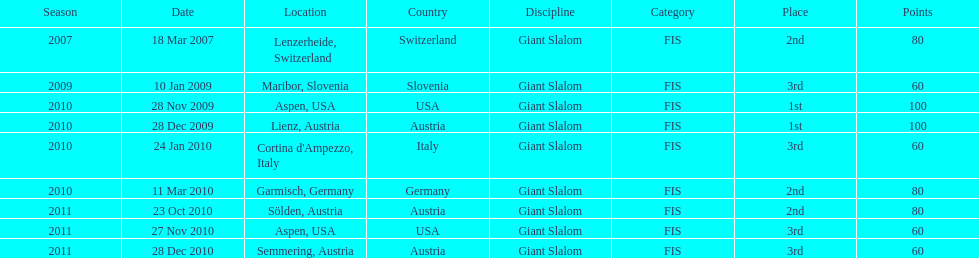What was the finishing place of the last race in december 2010? 3rd. I'm looking to parse the entire table for insights. Could you assist me with that? {'header': ['Season', 'Date', 'Location', 'Country', 'Discipline', 'Category', 'Place', 'Points'], 'rows': [['2007', '18 Mar 2007', 'Lenzerheide, Switzerland', 'Switzerland', 'Giant Slalom', 'FIS', '2nd', '80'], ['2009', '10 Jan 2009', 'Maribor, Slovenia', 'Slovenia', 'Giant Slalom', 'FIS', '3rd', '60'], ['2010', '28 Nov 2009', 'Aspen, USA', 'USA', 'Giant Slalom', 'FIS', '1st', '100'], ['2010', '28 Dec 2009', 'Lienz, Austria', 'Austria', 'Giant Slalom', 'FIS', '1st', '100'], ['2010', '24 Jan 2010', "Cortina d'Ampezzo, Italy", 'Italy', 'Giant Slalom', 'FIS', '3rd', '60'], ['2010', '11 Mar 2010', 'Garmisch, Germany', 'Germany', 'Giant Slalom', 'FIS', '2nd', '80'], ['2011', '23 Oct 2010', 'Sölden, Austria', 'Austria', 'Giant Slalom', 'FIS', '2nd', '80'], ['2011', '27 Nov 2010', 'Aspen, USA', 'USA', 'Giant Slalom', 'FIS', '3rd', '60'], ['2011', '28 Dec 2010', 'Semmering, Austria', 'Austria', 'Giant Slalom', 'FIS', '3rd', '60']]} 